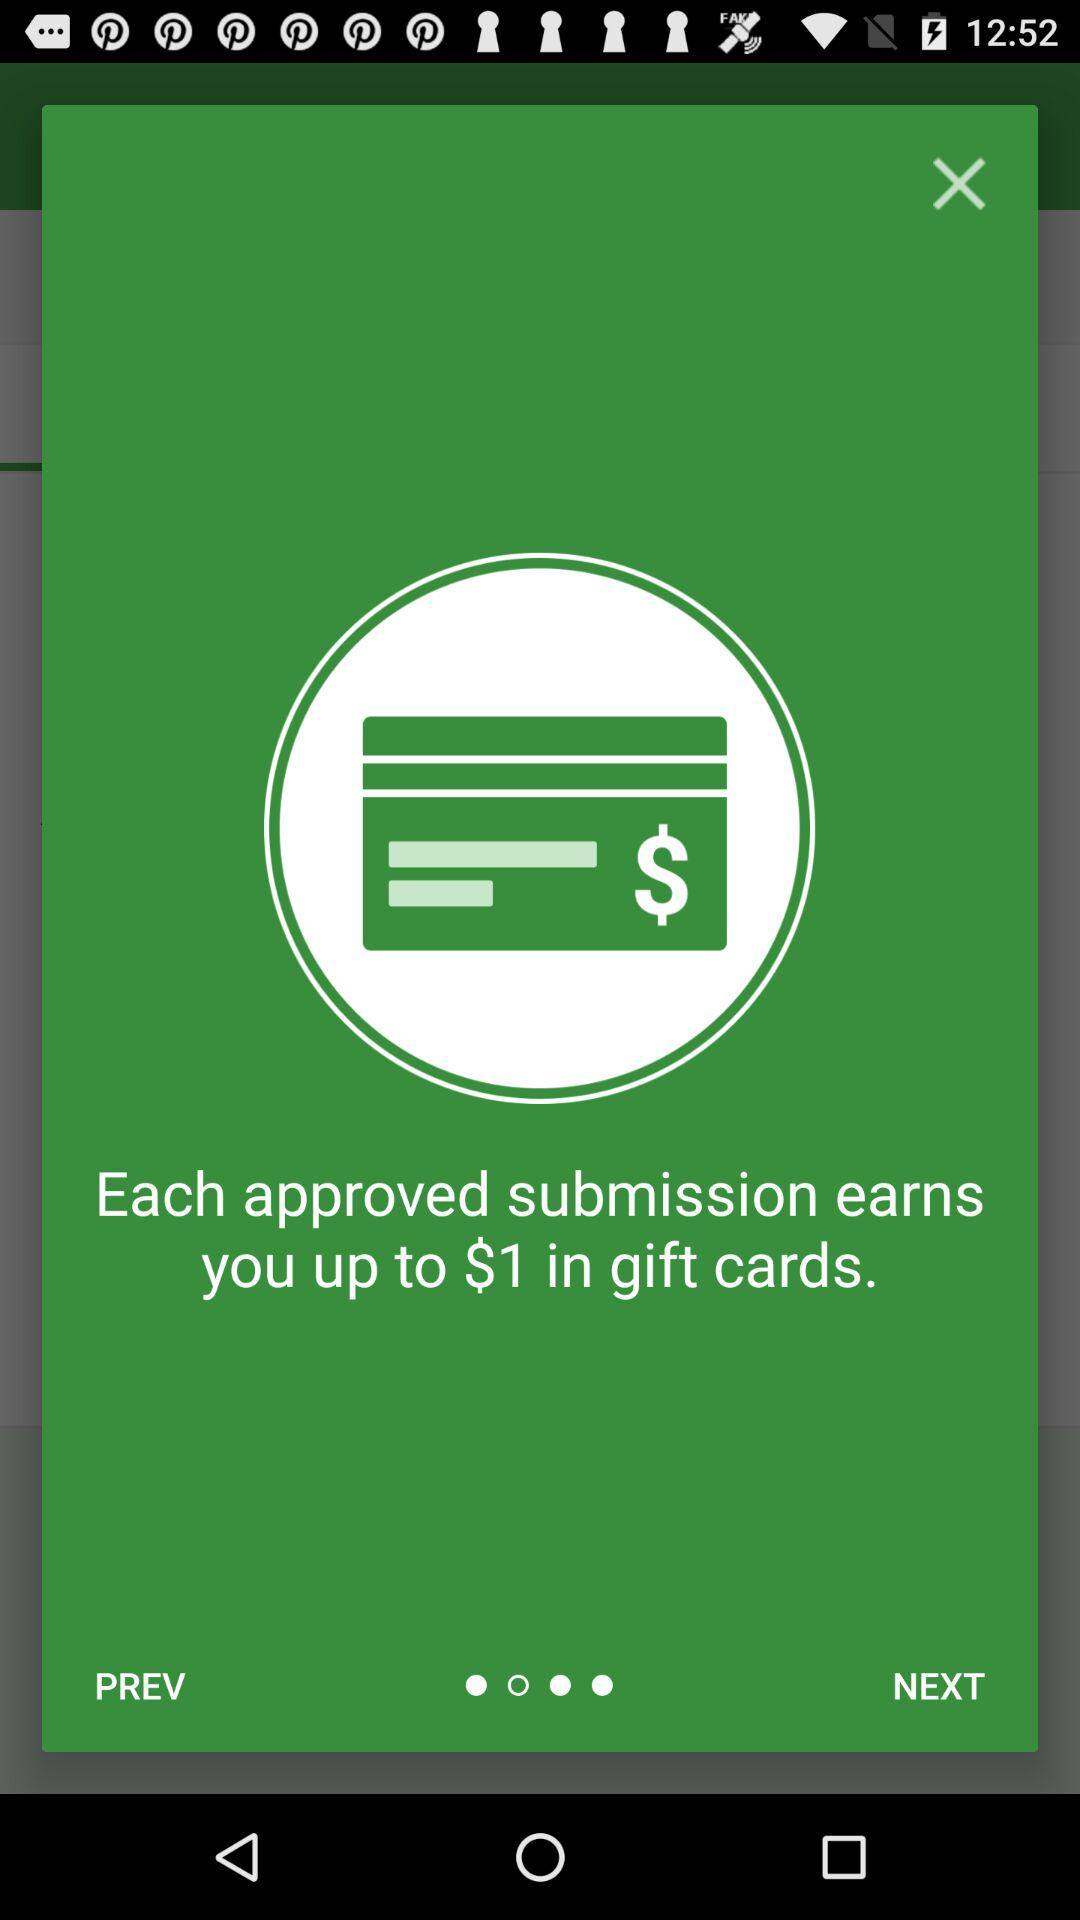How many $ in gift cards can I earn with each approved submission? You can earn up to $1 in gift cards with each approved submission. 